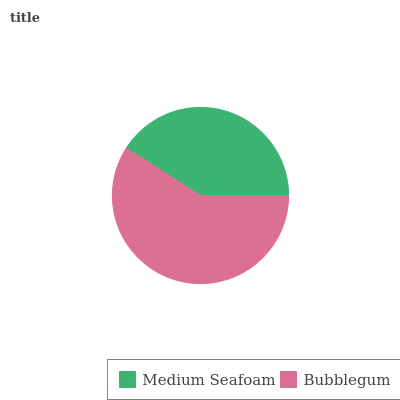Is Medium Seafoam the minimum?
Answer yes or no. Yes. Is Bubblegum the maximum?
Answer yes or no. Yes. Is Bubblegum the minimum?
Answer yes or no. No. Is Bubblegum greater than Medium Seafoam?
Answer yes or no. Yes. Is Medium Seafoam less than Bubblegum?
Answer yes or no. Yes. Is Medium Seafoam greater than Bubblegum?
Answer yes or no. No. Is Bubblegum less than Medium Seafoam?
Answer yes or no. No. Is Bubblegum the high median?
Answer yes or no. Yes. Is Medium Seafoam the low median?
Answer yes or no. Yes. Is Medium Seafoam the high median?
Answer yes or no. No. Is Bubblegum the low median?
Answer yes or no. No. 